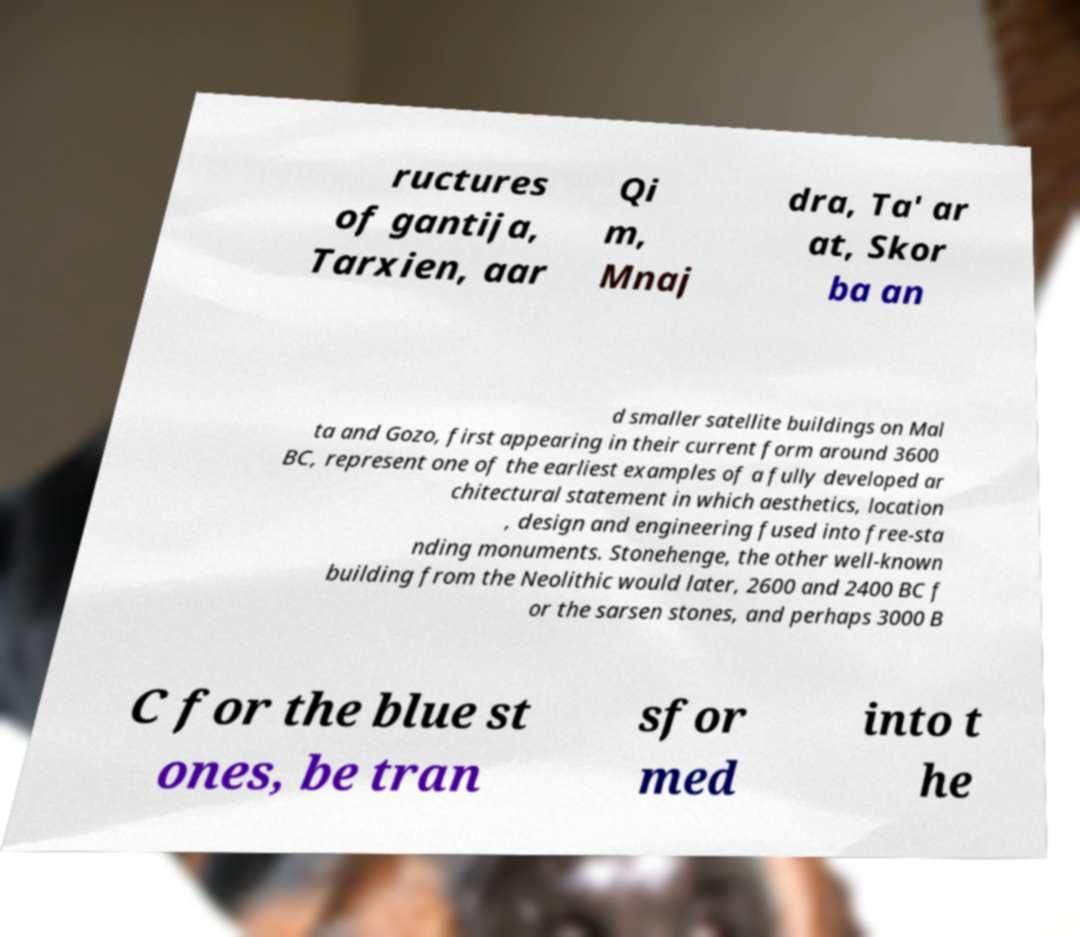What messages or text are displayed in this image? I need them in a readable, typed format. ructures of gantija, Tarxien, aar Qi m, Mnaj dra, Ta' ar at, Skor ba an d smaller satellite buildings on Mal ta and Gozo, first appearing in their current form around 3600 BC, represent one of the earliest examples of a fully developed ar chitectural statement in which aesthetics, location , design and engineering fused into free-sta nding monuments. Stonehenge, the other well-known building from the Neolithic would later, 2600 and 2400 BC f or the sarsen stones, and perhaps 3000 B C for the blue st ones, be tran sfor med into t he 